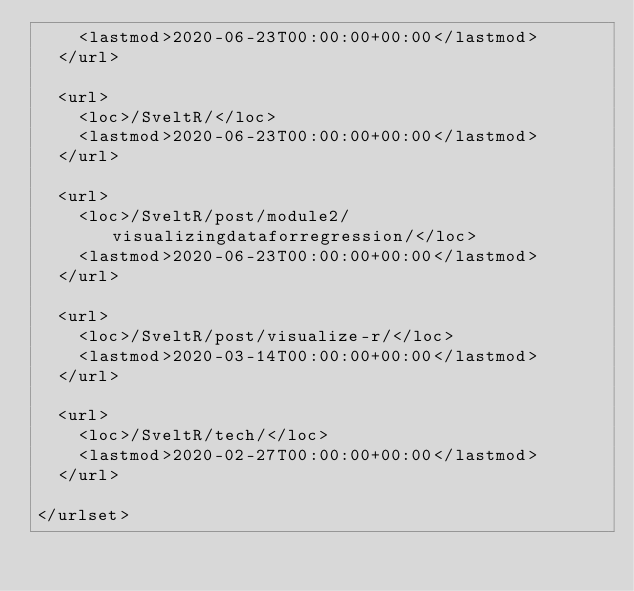Convert code to text. <code><loc_0><loc_0><loc_500><loc_500><_XML_>    <lastmod>2020-06-23T00:00:00+00:00</lastmod>
  </url>
  
  <url>
    <loc>/SveltR/</loc>
    <lastmod>2020-06-23T00:00:00+00:00</lastmod>
  </url>
  
  <url>
    <loc>/SveltR/post/module2/visualizingdataforregression/</loc>
    <lastmod>2020-06-23T00:00:00+00:00</lastmod>
  </url>
  
  <url>
    <loc>/SveltR/post/visualize-r/</loc>
    <lastmod>2020-03-14T00:00:00+00:00</lastmod>
  </url>
  
  <url>
    <loc>/SveltR/tech/</loc>
    <lastmod>2020-02-27T00:00:00+00:00</lastmod>
  </url>
  
</urlset></code> 